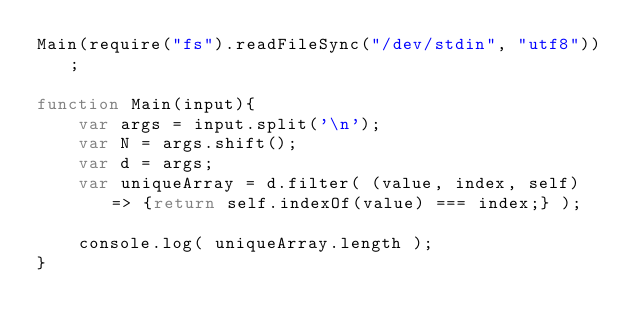Convert code to text. <code><loc_0><loc_0><loc_500><loc_500><_JavaScript_>Main(require("fs").readFileSync("/dev/stdin", "utf8"));

function Main(input){
    var args = input.split('\n');
    var N = args.shift();
    var d = args;
    var uniqueArray = d.filter( (value, index, self) => {return self.indexOf(value) === index;} );

    console.log( uniqueArray.length );
}</code> 